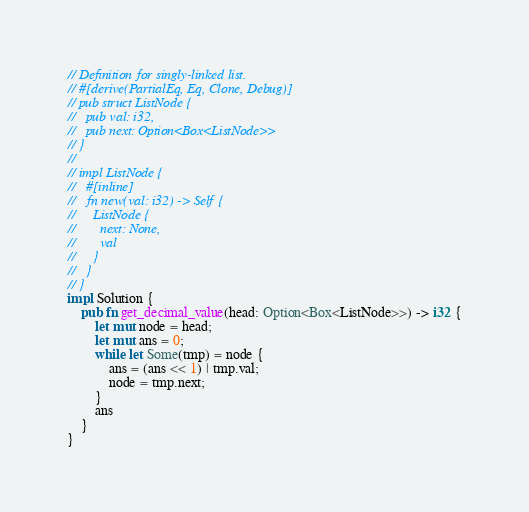Convert code to text. <code><loc_0><loc_0><loc_500><loc_500><_Rust_>// Definition for singly-linked list.
// #[derive(PartialEq, Eq, Clone, Debug)]
// pub struct ListNode {
//   pub val: i32,
//   pub next: Option<Box<ListNode>>
// }
// 
// impl ListNode {
//   #[inline]
//   fn new(val: i32) -> Self {
//     ListNode {
//       next: None,
//       val
//     }
//   }
// }
impl Solution {
    pub fn get_decimal_value(head: Option<Box<ListNode>>) -> i32 {
        let mut node = head;
        let mut ans = 0;
        while let Some(tmp) = node {
            ans = (ans << 1) | tmp.val;
            node = tmp.next;
        }
        ans
    }
}</code> 